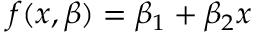Convert formula to latex. <formula><loc_0><loc_0><loc_500><loc_500>f ( x , { \beta } ) = \beta _ { 1 } + \beta _ { 2 } x</formula> 